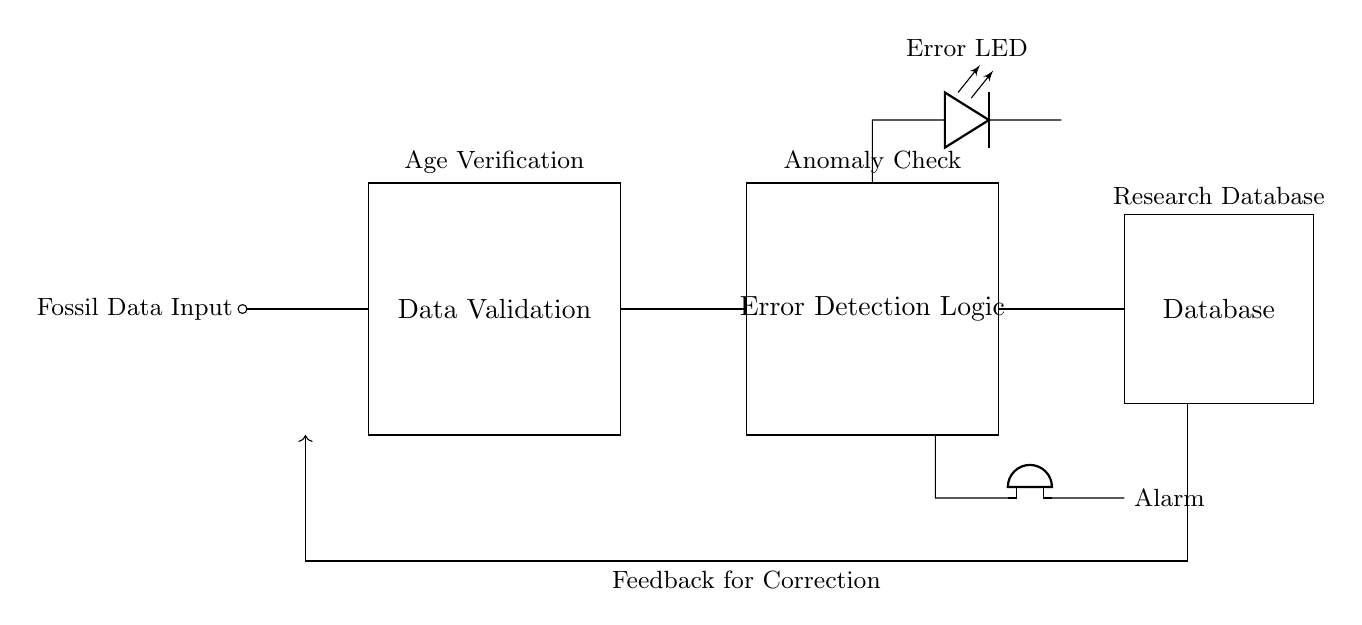What does the rectangular block labeled "Data Validation" represent in the circuit? The rectangular block labeled "Data Validation" indicates a process or function that verifies the accuracy and correctness of fossil data inputs before they are processed further.
Answer: Data Validation What component indicates an error in the circuit? The component that indicates an error in the circuit is the LED labeled "Error LED". The LED lights up when an error is detected during data validation.
Answer: Error LED How does the feedback loop function in the circuit? The feedback loop provides a path for returning to the "Fossil Data Input" once an error is detected, allowing for correction of the input data. It helps in ensuring the accuracy of the data entered into the system.
Answer: Feedback for Correction What type of alarm is indicated in the circuit? The circuit includes a buzzer as the alarm that activates when an error is detected in the data validation process.
Answer: Buzzer What process is indicated by the block labeled "Error Detection Logic"? The "Error Detection Logic" block represents the mechanism that analyzes the validated data to identify any discrepancies or anomalies, ensuring the integrity of the fossil data.
Answer: Error Detection Logic 